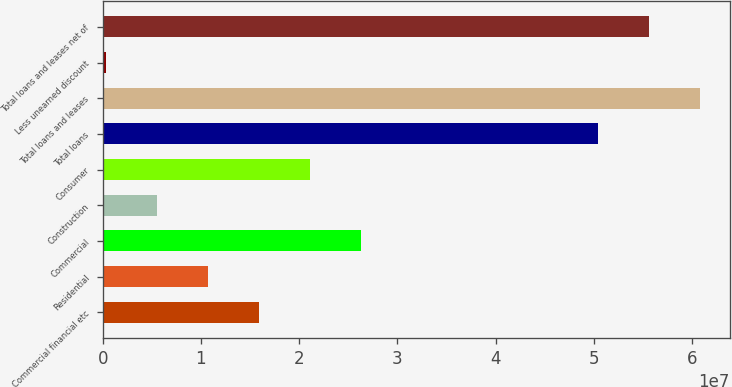Convert chart. <chart><loc_0><loc_0><loc_500><loc_500><bar_chart><fcel>Commercial financial etc<fcel>Residential<fcel>Commercial<fcel>Construction<fcel>Consumer<fcel>Total loans<fcel>Total loans and leases<fcel>Less unearned discount<fcel>Total loans and leases net of<nl><fcel>1.59508e+07<fcel>1.07571e+07<fcel>2.63381e+07<fcel>5.56344e+06<fcel>2.11444e+07<fcel>5.04292e+07<fcel>6.08165e+07<fcel>369771<fcel>5.56228e+07<nl></chart> 